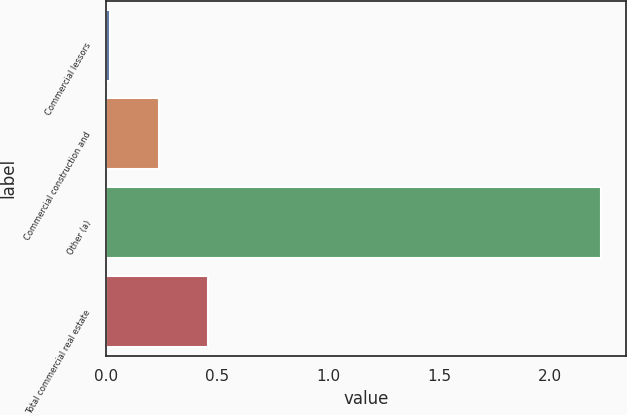<chart> <loc_0><loc_0><loc_500><loc_500><bar_chart><fcel>Commercial lessors<fcel>Commercial construction and<fcel>Other (a)<fcel>Total commercial real estate<nl><fcel>0.02<fcel>0.24<fcel>2.23<fcel>0.46<nl></chart> 